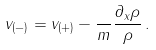<formula> <loc_0><loc_0><loc_500><loc_500>v _ { ( - ) } = v _ { ( + ) } - \frac { } { m } \frac { \partial _ { x } \rho } { \rho } \, .</formula> 